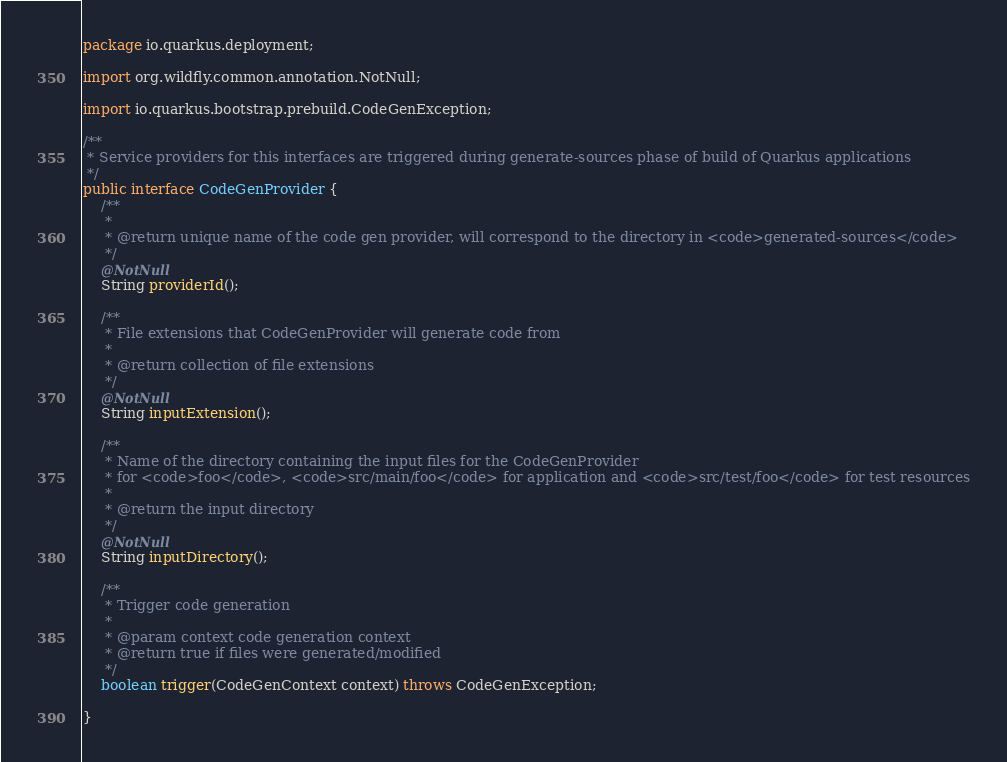<code> <loc_0><loc_0><loc_500><loc_500><_Java_>package io.quarkus.deployment;

import org.wildfly.common.annotation.NotNull;

import io.quarkus.bootstrap.prebuild.CodeGenException;

/**
 * Service providers for this interfaces are triggered during generate-sources phase of build of Quarkus applications
 */
public interface CodeGenProvider {
    /**
     *
     * @return unique name of the code gen provider, will correspond to the directory in <code>generated-sources</code>
     */
    @NotNull
    String providerId();

    /**
     * File extensions that CodeGenProvider will generate code from
     *
     * @return collection of file extensions
     */
    @NotNull
    String inputExtension();

    /**
     * Name of the directory containing the input files for the CodeGenProvider
     * for <code>foo</code>, <code>src/main/foo</code> for application and <code>src/test/foo</code> for test resources
     *
     * @return the input directory
     */
    @NotNull
    String inputDirectory();

    /**
     * Trigger code generation
     * 
     * @param context code generation context
     * @return true if files were generated/modified
     */
    boolean trigger(CodeGenContext context) throws CodeGenException;

}
</code> 